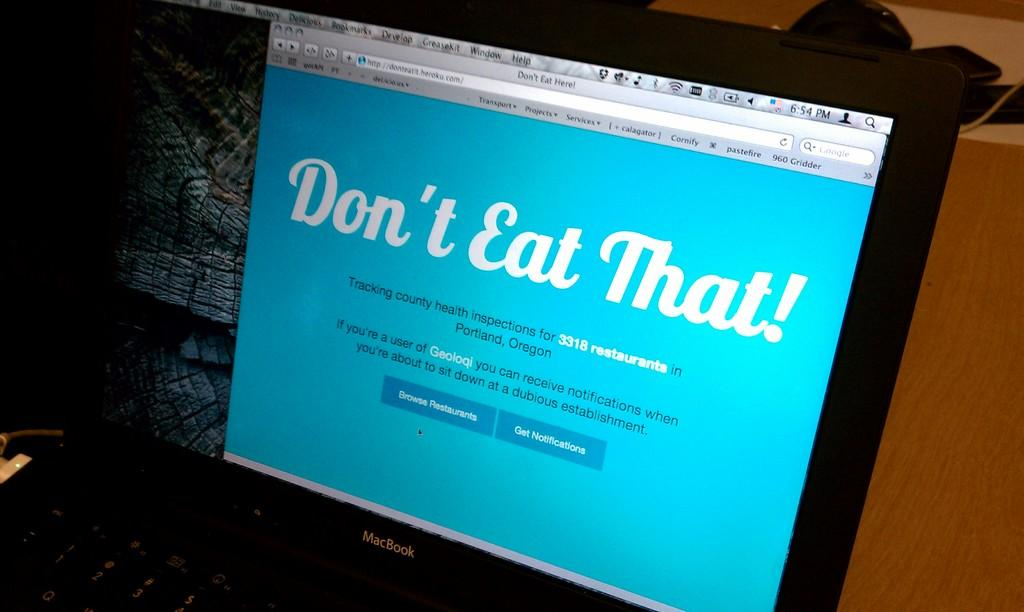<image>
Render a clear and concise summary of the photo. A website provides an option to receive notifications. 